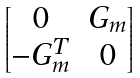Convert formula to latex. <formula><loc_0><loc_0><loc_500><loc_500>\begin{bmatrix} 0 & G _ { m } \\ - G _ { m } ^ { T } & 0 \\ \end{bmatrix}</formula> 